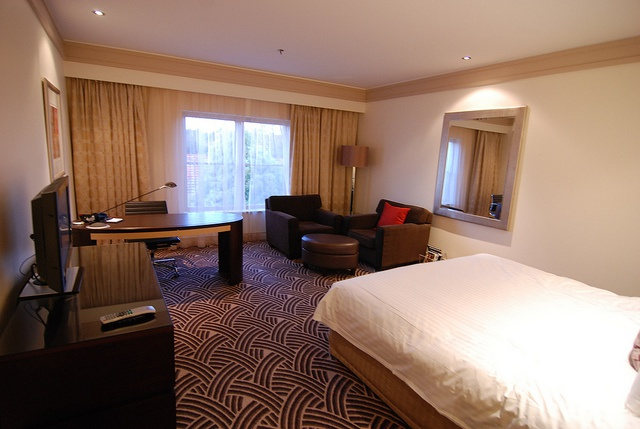Describe the objects in this image and their specific colors. I can see bed in gray, white, and tan tones, tv in gray, black, maroon, and brown tones, chair in gray, maroon, and black tones, chair in gray, black, maroon, and purple tones, and chair in gray, black, and maroon tones in this image. 